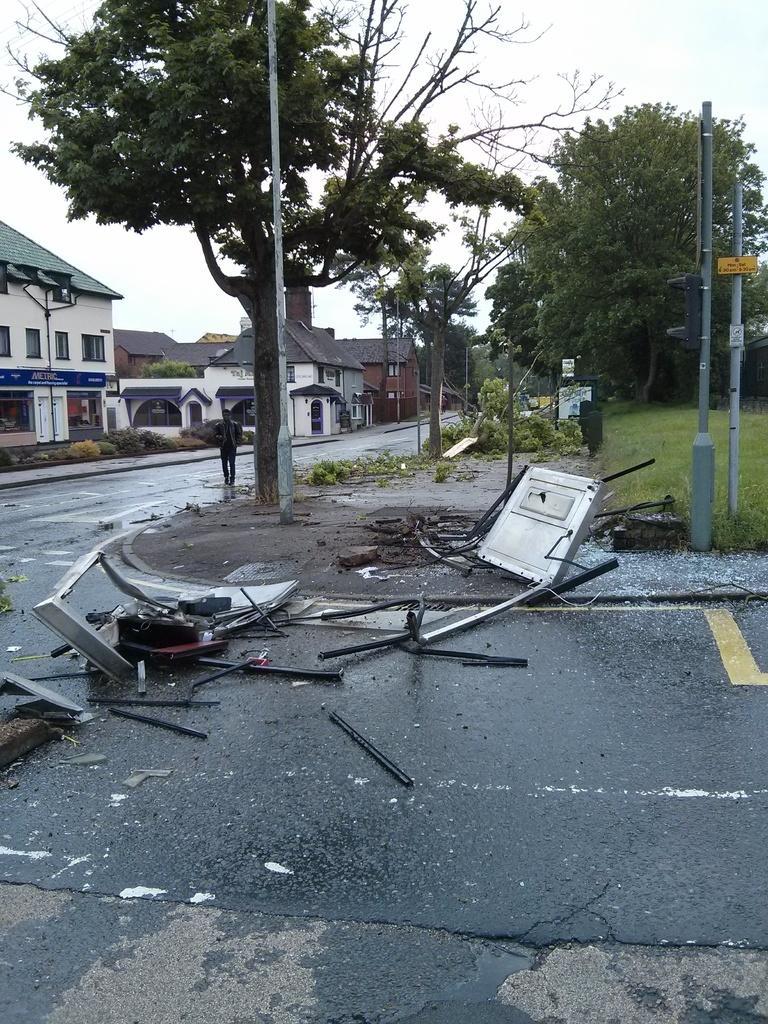Can you describe this image briefly? This is an outside view. At the bottom few metal objects are placed on the road. Beside the road there are poles and trees. On the right side, I can see the grass on the ground. In the background there are few buildings. One person is walking on the road. At the top of the image I can see the sky. 